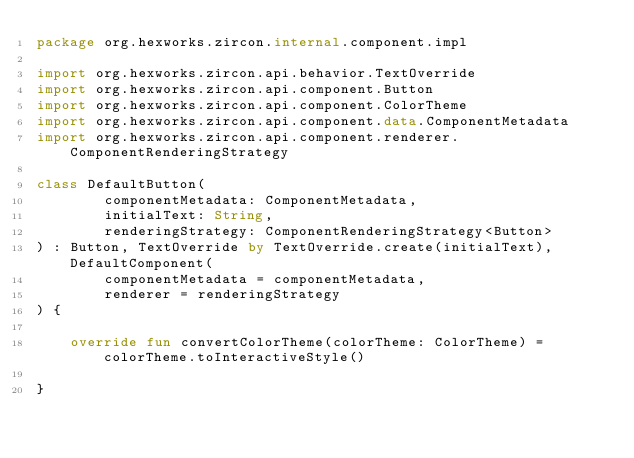<code> <loc_0><loc_0><loc_500><loc_500><_Kotlin_>package org.hexworks.zircon.internal.component.impl

import org.hexworks.zircon.api.behavior.TextOverride
import org.hexworks.zircon.api.component.Button
import org.hexworks.zircon.api.component.ColorTheme
import org.hexworks.zircon.api.component.data.ComponentMetadata
import org.hexworks.zircon.api.component.renderer.ComponentRenderingStrategy

class DefaultButton(
        componentMetadata: ComponentMetadata,
        initialText: String,
        renderingStrategy: ComponentRenderingStrategy<Button>
) : Button, TextOverride by TextOverride.create(initialText), DefaultComponent(
        componentMetadata = componentMetadata,
        renderer = renderingStrategy
) {

    override fun convertColorTheme(colorTheme: ColorTheme) = colorTheme.toInteractiveStyle()

}
</code> 